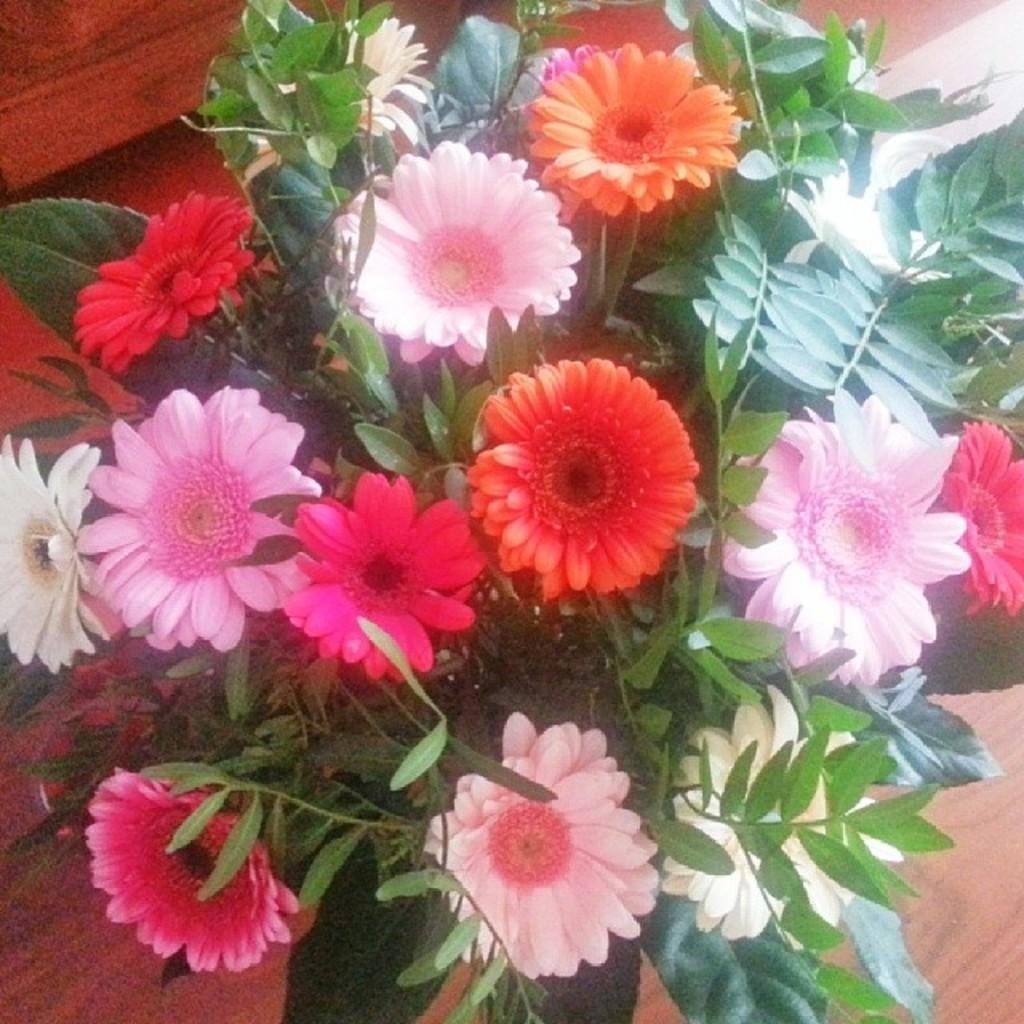Could you give a brief overview of what you see in this image? In the image we can see there are flowers of different colors. These are the leaves and this is a wooden surface. 